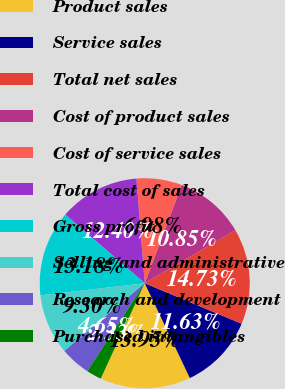Convert chart. <chart><loc_0><loc_0><loc_500><loc_500><pie_chart><fcel>Product sales<fcel>Service sales<fcel>Total net sales<fcel>Cost of product sales<fcel>Cost of service sales<fcel>Total cost of sales<fcel>Gross profit<fcel>Selling and administrative<fcel>Research and development<fcel>Purchased intangibles<nl><fcel>13.95%<fcel>11.63%<fcel>14.73%<fcel>10.85%<fcel>6.98%<fcel>12.4%<fcel>13.18%<fcel>9.3%<fcel>4.65%<fcel>2.33%<nl></chart> 